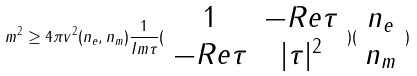<formula> <loc_0><loc_0><loc_500><loc_500>m ^ { 2 } \geq 4 \pi v ^ { 2 } ( n _ { e } , n _ { m } ) \frac { 1 } { I m \tau } ( \begin{array} { c c } 1 & - R e \tau \\ - R e \tau & | \tau | ^ { 2 } \end{array} ) ( \begin{array} { c } n _ { e } \\ n _ { m } \end{array} )</formula> 